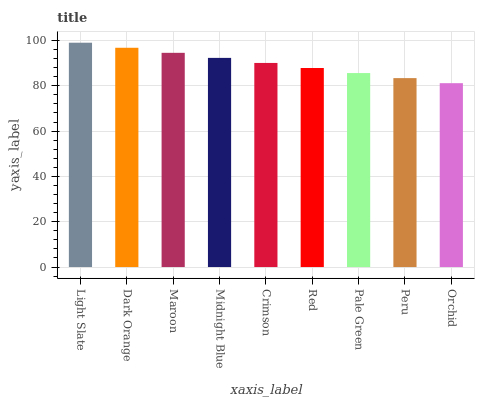Is Orchid the minimum?
Answer yes or no. Yes. Is Light Slate the maximum?
Answer yes or no. Yes. Is Dark Orange the minimum?
Answer yes or no. No. Is Dark Orange the maximum?
Answer yes or no. No. Is Light Slate greater than Dark Orange?
Answer yes or no. Yes. Is Dark Orange less than Light Slate?
Answer yes or no. Yes. Is Dark Orange greater than Light Slate?
Answer yes or no. No. Is Light Slate less than Dark Orange?
Answer yes or no. No. Is Crimson the high median?
Answer yes or no. Yes. Is Crimson the low median?
Answer yes or no. Yes. Is Maroon the high median?
Answer yes or no. No. Is Peru the low median?
Answer yes or no. No. 